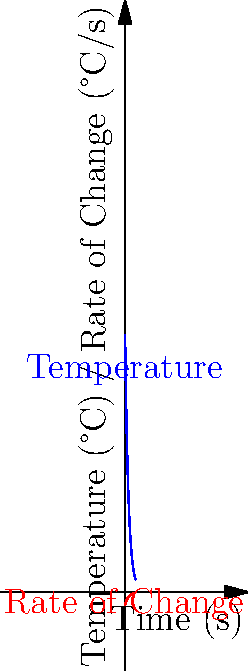A heat shield's temperature during reentry is modeled by the function $T(t) = 1500e^{-0.05t}$, where $T$ is in °C and $t$ is in seconds. At what time does the rate of temperature change equal -50°C/s? To solve this problem, we need to follow these steps:

1) First, we need to find the rate of change of temperature. This is given by the derivative of $T(t)$:

   $\frac{dT}{dt} = -75e^{-0.05t}$

2) We want to find when this rate equals -50°C/s. So we set up the equation:

   $-75e^{-0.05t} = -50$

3) Now we solve for $t$:
   
   $e^{-0.05t} = \frac{50}{75} = \frac{2}{3}$

4) Taking the natural log of both sides:

   $-0.05t = \ln(\frac{2}{3})$

5) Solving for $t$:

   $t = -\frac{\ln(\frac{2}{3})}{0.05} \approx 8.11$ seconds

Therefore, the rate of temperature change equals -50°C/s after approximately 8.11 seconds.
Answer: 8.11 seconds 